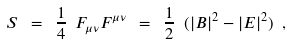Convert formula to latex. <formula><loc_0><loc_0><loc_500><loc_500>S \ = \ \frac { 1 } { 4 } \ F _ { \mu \nu } F ^ { \mu \nu } \ = \ \frac { 1 } { 2 } \ ( | B | ^ { 2 } - | E | ^ { 2 } ) \ ,</formula> 